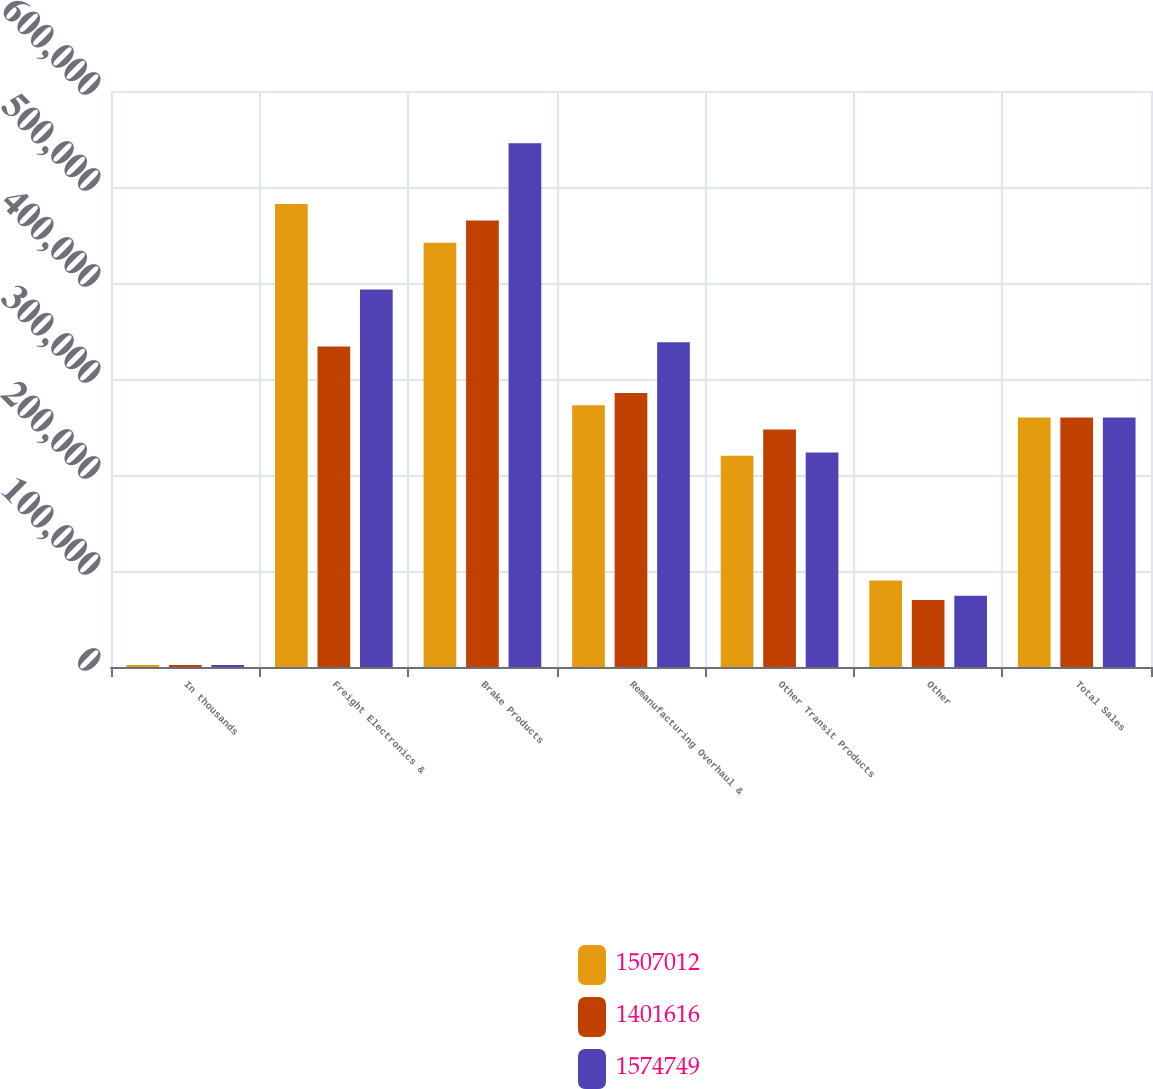Convert chart to OTSL. <chart><loc_0><loc_0><loc_500><loc_500><stacked_bar_chart><ecel><fcel>In thousands<fcel>Freight Electronics &<fcel>Brake Products<fcel>Remanufacturing Overhaul &<fcel>Other Transit Products<fcel>Other<fcel>Total Sales<nl><fcel>1.50701e+06<fcel>2010<fcel>482406<fcel>441831<fcel>272527<fcel>220152<fcel>90096<fcel>260006<nl><fcel>1.40162e+06<fcel>2009<fcel>333760<fcel>465079<fcel>285466<fcel>247485<fcel>69826<fcel>260006<nl><fcel>1.57475e+06<fcel>2008<fcel>393288<fcel>545528<fcel>338354<fcel>223419<fcel>74160<fcel>260006<nl></chart> 